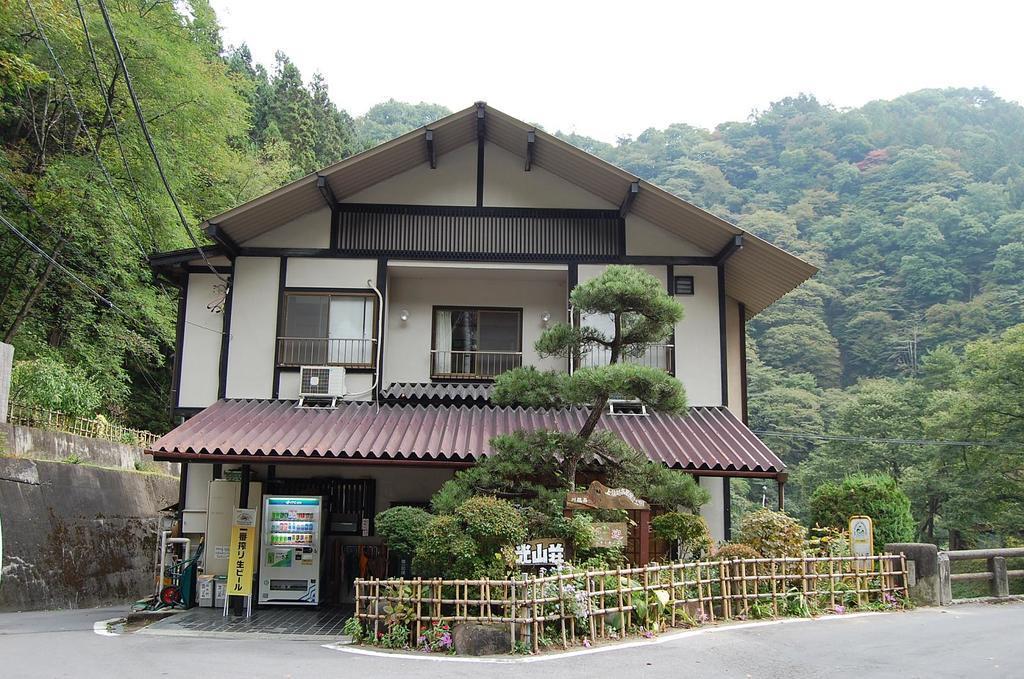Please provide a concise description of this image. In this picture we can see the road, machine, fences, walls, poster, trees, building with windows, some objects and in the background we can see the sky. 